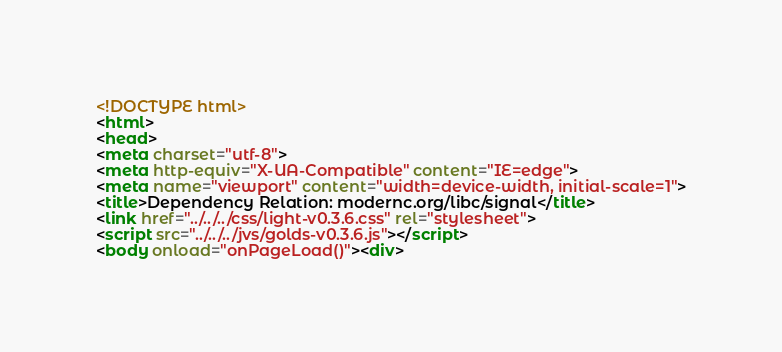<code> <loc_0><loc_0><loc_500><loc_500><_HTML_><!DOCTYPE html>
<html>
<head>
<meta charset="utf-8">
<meta http-equiv="X-UA-Compatible" content="IE=edge">
<meta name="viewport" content="width=device-width, initial-scale=1">
<title>Dependency Relation: modernc.org/libc/signal</title>
<link href="../../../css/light-v0.3.6.css" rel="stylesheet">
<script src="../../../jvs/golds-v0.3.6.js"></script>
<body onload="onPageLoad()"><div>
</code> 